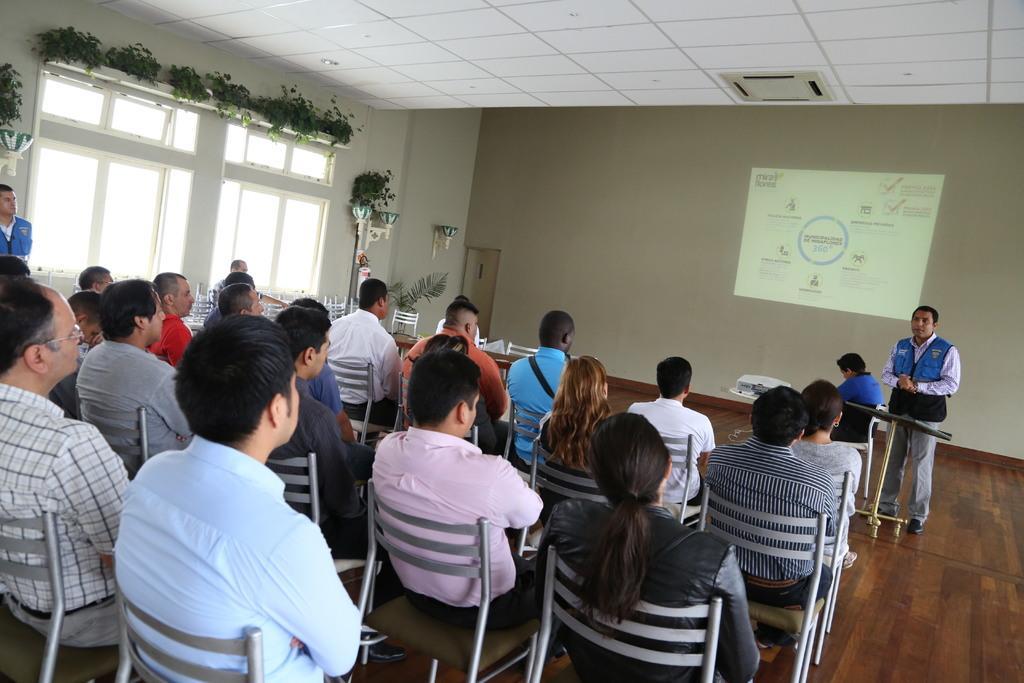In one or two sentences, can you explain what this image depicts? In this image there are a group of people sitting in chairs, beside them there is a person standing, behind him there are flower pots, plants on the walls and there are glass windows with curtains, in front of the image there is a person standing, in front of him on the stand there are some objects, beside him there is another person sitting in a chair, in front of him there is a projector on a stool, in the background of the image there is a wall with a screen, on the corner of the wall there is a door, at the top of the image there is an air conditioner on the roof. 